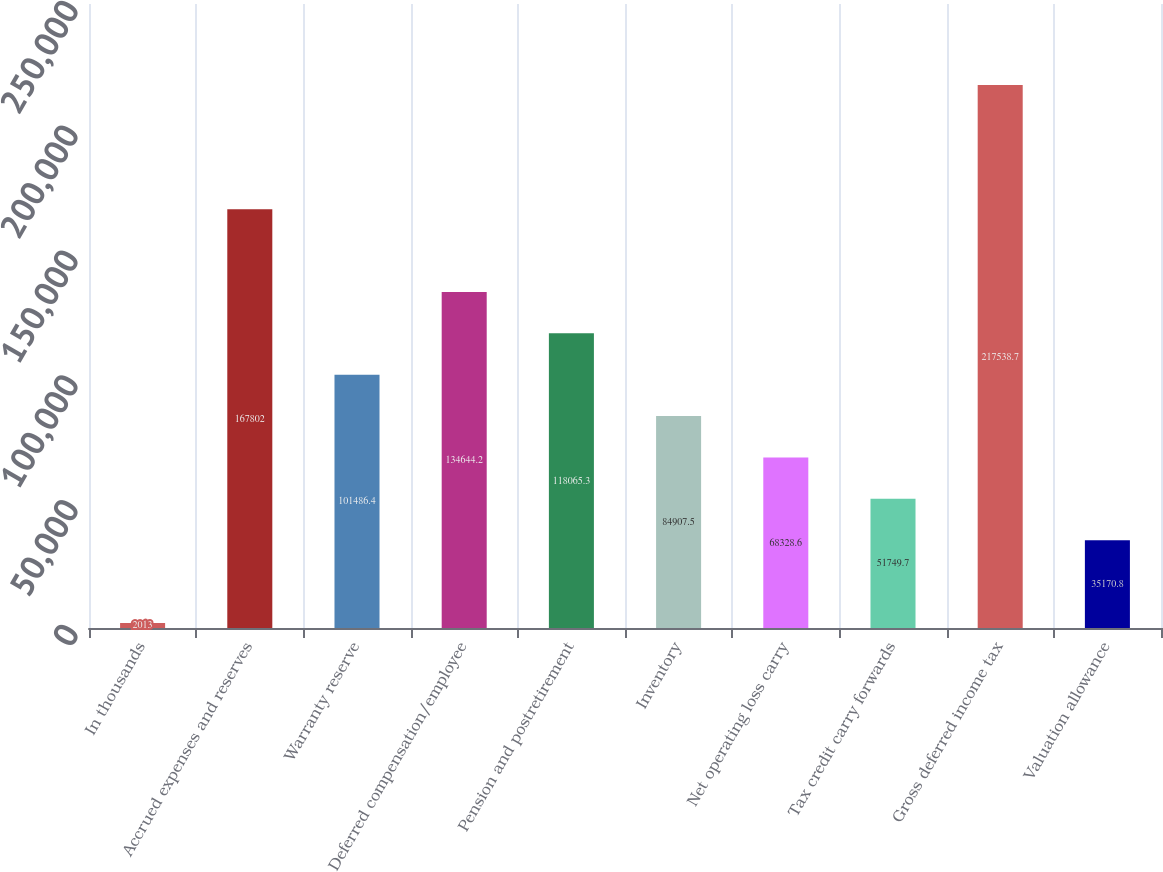Convert chart to OTSL. <chart><loc_0><loc_0><loc_500><loc_500><bar_chart><fcel>In thousands<fcel>Accrued expenses and reserves<fcel>Warranty reserve<fcel>Deferred compensation/employee<fcel>Pension and postretirement<fcel>Inventory<fcel>Net operating loss carry<fcel>Tax credit carry forwards<fcel>Gross deferred income tax<fcel>Valuation allowance<nl><fcel>2013<fcel>167802<fcel>101486<fcel>134644<fcel>118065<fcel>84907.5<fcel>68328.6<fcel>51749.7<fcel>217539<fcel>35170.8<nl></chart> 